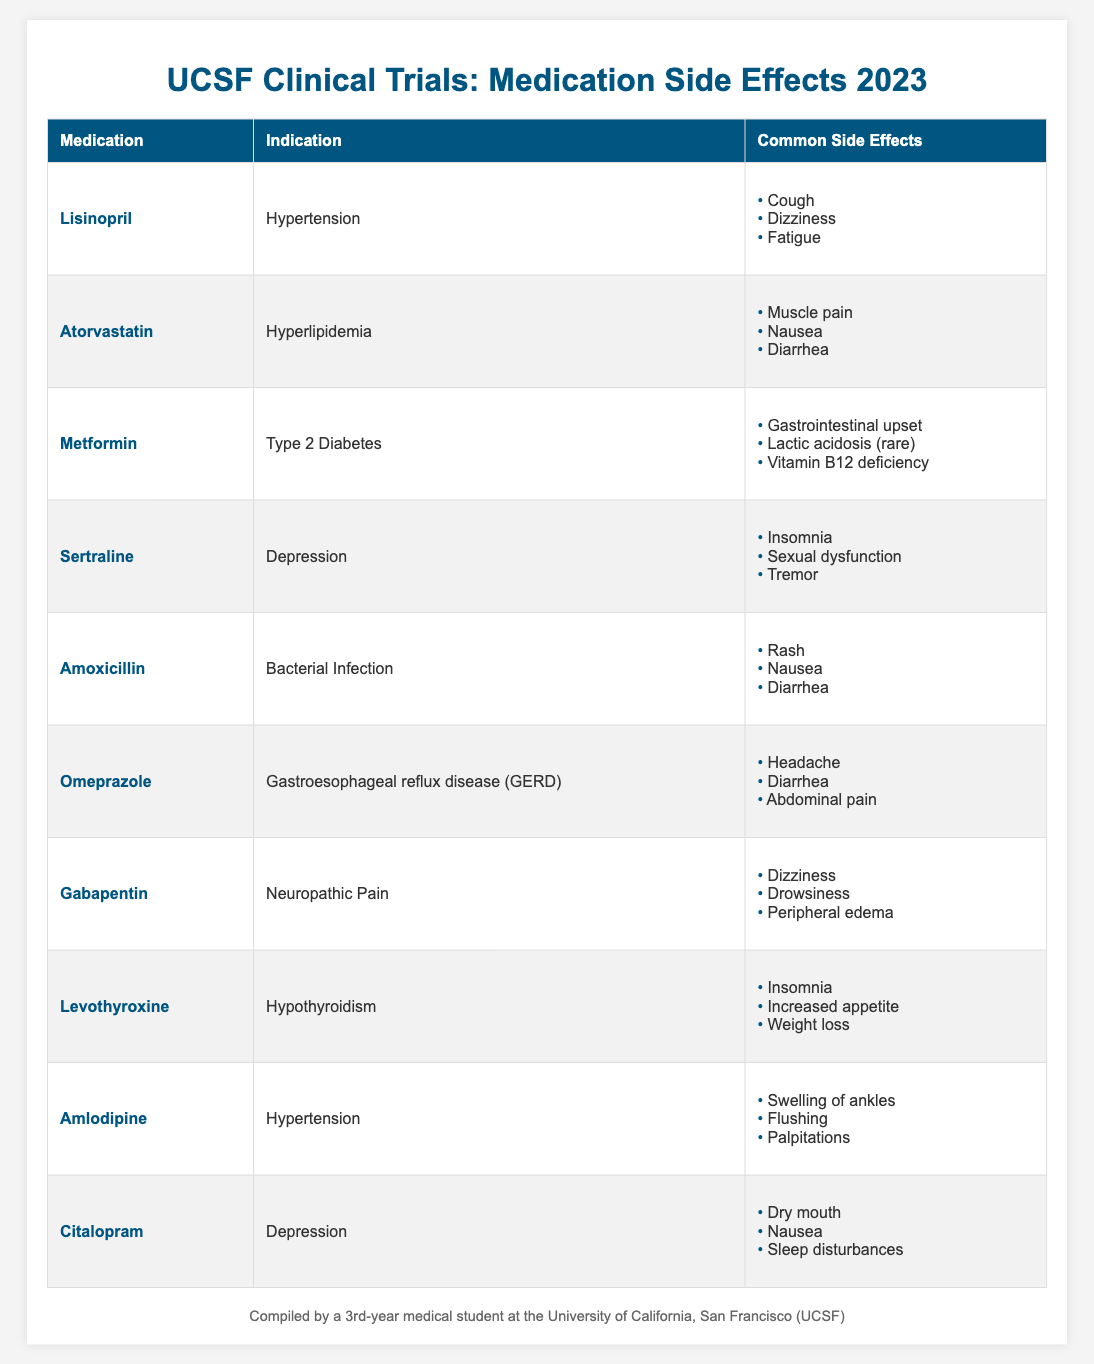What medication is prescribed for Hypertension? The table lists "Lisinopril" and "Amlodipine" as medications prescribed for Hypertension in the 'Indication' column.
Answer: Lisinopril and Amlodipine Which medication has a side effect of 'Diarrhea'? The side effect 'Diarrhea' is listed for Atorvastatin, Amoxicillin, and Omeprazole in the 'Common Side Effects' column.
Answer: Atorvastatin, Amoxicillin, Omeprazole How many medications are indicated for Depression? The table lists "Sertraline" and "Citalopram" under the indication for Depression, indicating that there are 2 medications.
Answer: 2 Is 'Weight loss' a common side effect of Levothyroxine? The table shows that 'Weight loss' is indeed listed as a common side effect of Levothyroxine, confirming that the statement is true.
Answer: Yes What is the total number of medications listed in the table? By counting the rows in the 'medications' section of the table, there are 10 medications listed.
Answer: 10 Which medication indicated for Hyperlipidemia is associated with muscle pain as a side effect? The table indicates that Atorvastatin is prescribed for Hyperlipidemia and lists muscle pain among its common side effects.
Answer: Atorvastatin What percentage of the medications listed have dizziness as a side effect? The medications Gabapentin and Lisinopril both list dizziness as a common side effect, making 2 out of 10 total medications. Thus, (2/10) * 100 = 20%.
Answer: 20% Which medication has the least number of common side effects? Metformin has 3 common side effects: gastrointestinal upset, lactic acidosis (rare), and vitamin B12 deficiency, which is the least compared to other medications.
Answer: Metformin Is there any medication that indicates gastrointestinal upset as a side effect? The table confirms that Metformin has gastrointestinal upset as one of its common side effects. Therefore, the answer is yes.
Answer: Yes If you were to list the medications prescribed for Hypertension, what are they? The medications prescribed for Hypertension are Lisinopril and Amlodipine, as highlighted in the table under the Indication column.
Answer: Lisinopril, Amlodipine What side effect appears most frequently across all medications? Dizziness appears as a side effect in both Lisinopril and Gabapentin, making it a frequent side effect among the listed medications.
Answer: Dizziness 